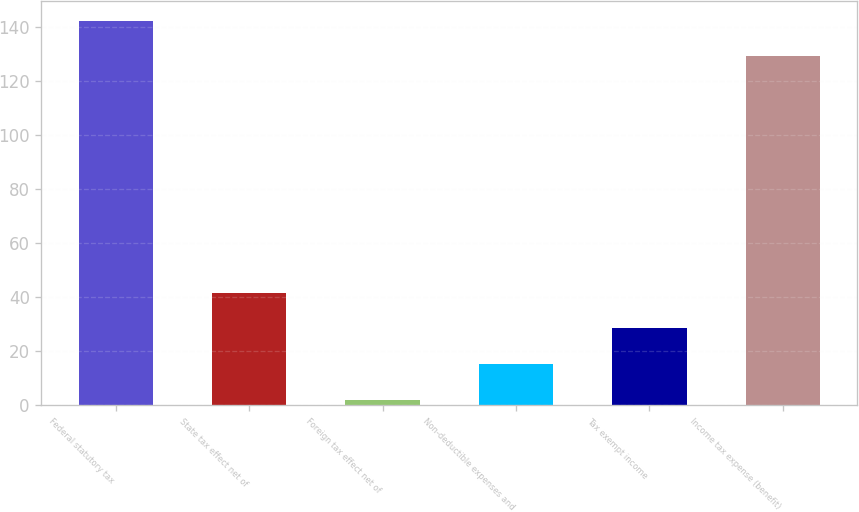Convert chart to OTSL. <chart><loc_0><loc_0><loc_500><loc_500><bar_chart><fcel>Federal statutory tax<fcel>State tax effect net of<fcel>Foreign tax effect net of<fcel>Non-deductible expenses and<fcel>Tax exempt income<fcel>Income tax expense (benefit)<nl><fcel>142.2<fcel>41.6<fcel>2<fcel>15.2<fcel>28.4<fcel>129<nl></chart> 